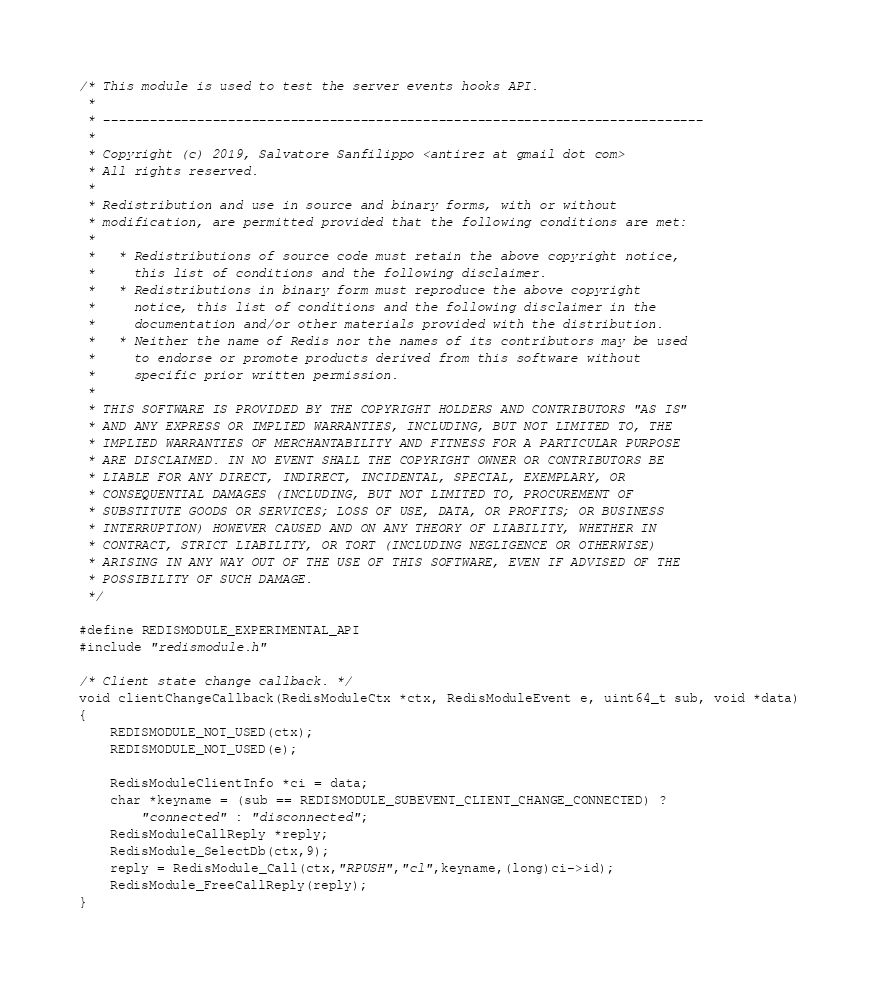Convert code to text. <code><loc_0><loc_0><loc_500><loc_500><_C_>/* This module is used to test the server events hooks API.
 *
 * -----------------------------------------------------------------------------
 *
 * Copyright (c) 2019, Salvatore Sanfilippo <antirez at gmail dot com>
 * All rights reserved.
 *
 * Redistribution and use in source and binary forms, with or without
 * modification, are permitted provided that the following conditions are met:
 *
 *   * Redistributions of source code must retain the above copyright notice,
 *     this list of conditions and the following disclaimer.
 *   * Redistributions in binary form must reproduce the above copyright
 *     notice, this list of conditions and the following disclaimer in the
 *     documentation and/or other materials provided with the distribution.
 *   * Neither the name of Redis nor the names of its contributors may be used
 *     to endorse or promote products derived from this software without
 *     specific prior written permission.
 *
 * THIS SOFTWARE IS PROVIDED BY THE COPYRIGHT HOLDERS AND CONTRIBUTORS "AS IS"
 * AND ANY EXPRESS OR IMPLIED WARRANTIES, INCLUDING, BUT NOT LIMITED TO, THE
 * IMPLIED WARRANTIES OF MERCHANTABILITY AND FITNESS FOR A PARTICULAR PURPOSE
 * ARE DISCLAIMED. IN NO EVENT SHALL THE COPYRIGHT OWNER OR CONTRIBUTORS BE
 * LIABLE FOR ANY DIRECT, INDIRECT, INCIDENTAL, SPECIAL, EXEMPLARY, OR
 * CONSEQUENTIAL DAMAGES (INCLUDING, BUT NOT LIMITED TO, PROCUREMENT OF
 * SUBSTITUTE GOODS OR SERVICES; LOSS OF USE, DATA, OR PROFITS; OR BUSINESS
 * INTERRUPTION) HOWEVER CAUSED AND ON ANY THEORY OF LIABILITY, WHETHER IN
 * CONTRACT, STRICT LIABILITY, OR TORT (INCLUDING NEGLIGENCE OR OTHERWISE)
 * ARISING IN ANY WAY OUT OF THE USE OF THIS SOFTWARE, EVEN IF ADVISED OF THE
 * POSSIBILITY OF SUCH DAMAGE.
 */

#define REDISMODULE_EXPERIMENTAL_API
#include "redismodule.h"

/* Client state change callback. */
void clientChangeCallback(RedisModuleCtx *ctx, RedisModuleEvent e, uint64_t sub, void *data)
{
    REDISMODULE_NOT_USED(ctx);
    REDISMODULE_NOT_USED(e);

    RedisModuleClientInfo *ci = data;
    char *keyname = (sub == REDISMODULE_SUBEVENT_CLIENT_CHANGE_CONNECTED) ?
        "connected" : "disconnected";
    RedisModuleCallReply *reply;
    RedisModule_SelectDb(ctx,9);
    reply = RedisModule_Call(ctx,"RPUSH","cl",keyname,(long)ci->id);
    RedisModule_FreeCallReply(reply);
}
</code> 